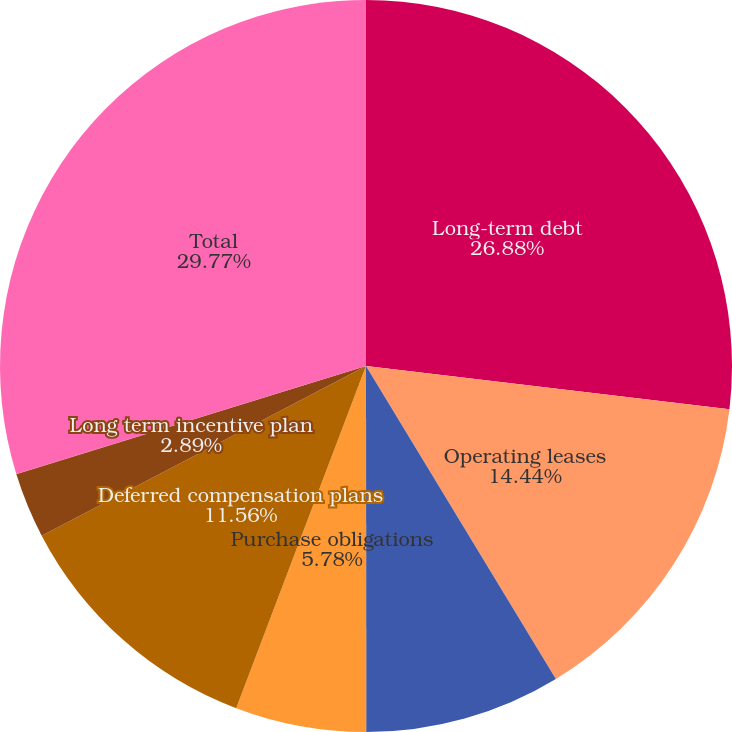Convert chart to OTSL. <chart><loc_0><loc_0><loc_500><loc_500><pie_chart><fcel>Long-term debt<fcel>Operating leases<fcel>Outstanding letters of credit<fcel>Purchase obligations<fcel>Deferred compensation plans<fcel>Long term incentive plan<fcel>FIN 48 liability<fcel>Total<nl><fcel>26.88%<fcel>14.44%<fcel>8.67%<fcel>5.78%<fcel>11.56%<fcel>2.89%<fcel>0.01%<fcel>29.77%<nl></chart> 